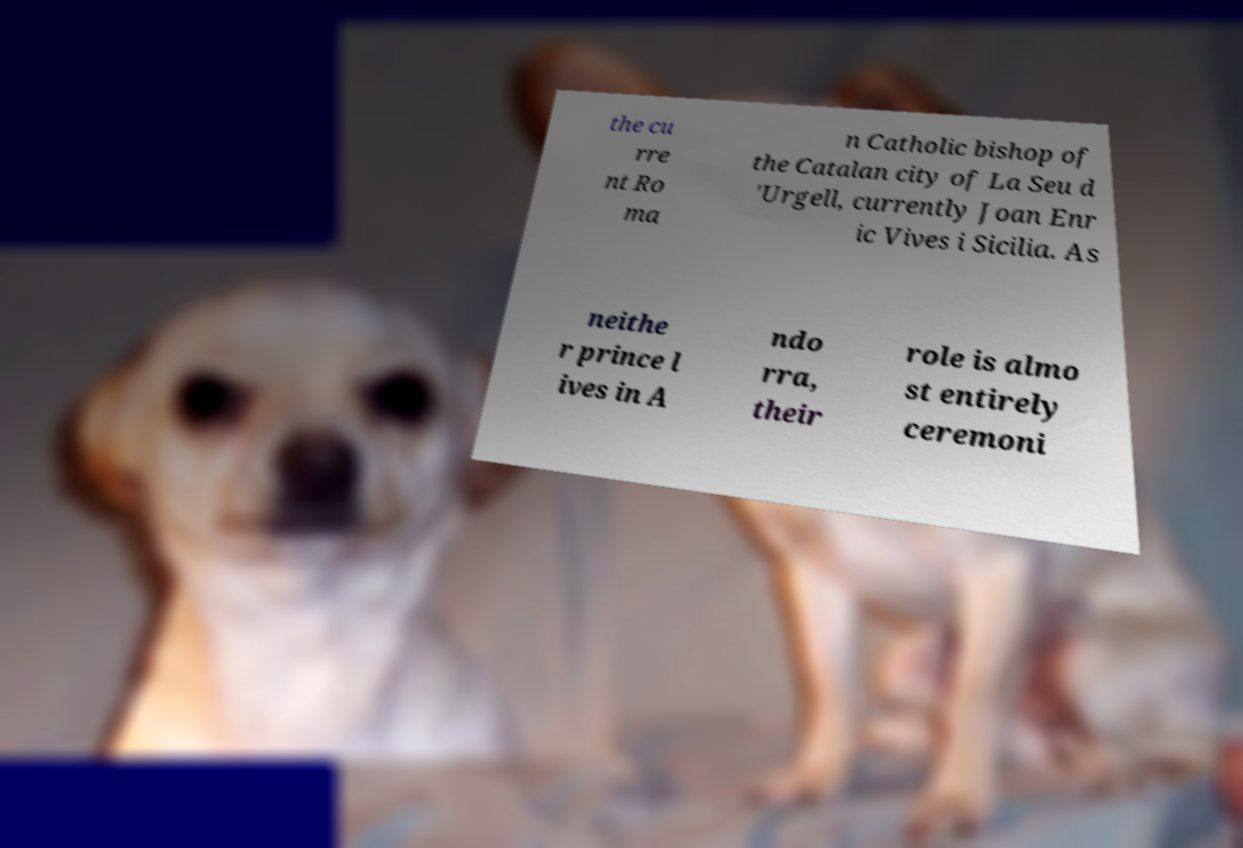Could you assist in decoding the text presented in this image and type it out clearly? the cu rre nt Ro ma n Catholic bishop of the Catalan city of La Seu d 'Urgell, currently Joan Enr ic Vives i Sicilia. As neithe r prince l ives in A ndo rra, their role is almo st entirely ceremoni 